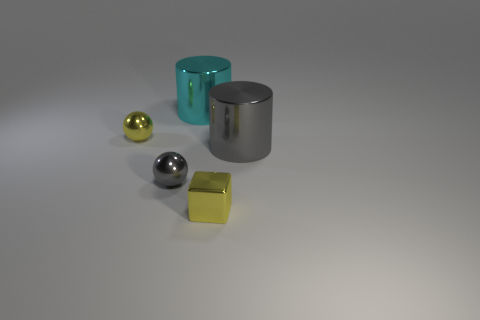Add 5 shiny blocks. How many objects exist? 10 Subtract all spheres. How many objects are left? 3 Add 5 yellow metallic balls. How many yellow metallic balls exist? 6 Subtract 0 green cylinders. How many objects are left? 5 Subtract all green shiny objects. Subtract all yellow metal spheres. How many objects are left? 4 Add 1 tiny gray spheres. How many tiny gray spheres are left? 2 